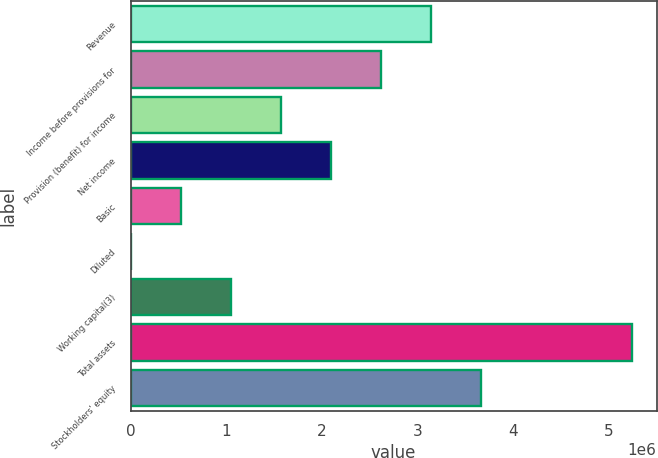Convert chart to OTSL. <chart><loc_0><loc_0><loc_500><loc_500><bar_chart><fcel>Revenue<fcel>Income before provisions for<fcel>Provision (benefit) for income<fcel>Net income<fcel>Basic<fcel>Diluted<fcel>Working capital(3)<fcel>Total assets<fcel>Stockholders' equity<nl><fcel>3.14422e+06<fcel>2.62018e+06<fcel>1.57211e+06<fcel>2.09615e+06<fcel>524038<fcel>1.73<fcel>1.04807e+06<fcel>5.24036e+06<fcel>3.66826e+06<nl></chart> 